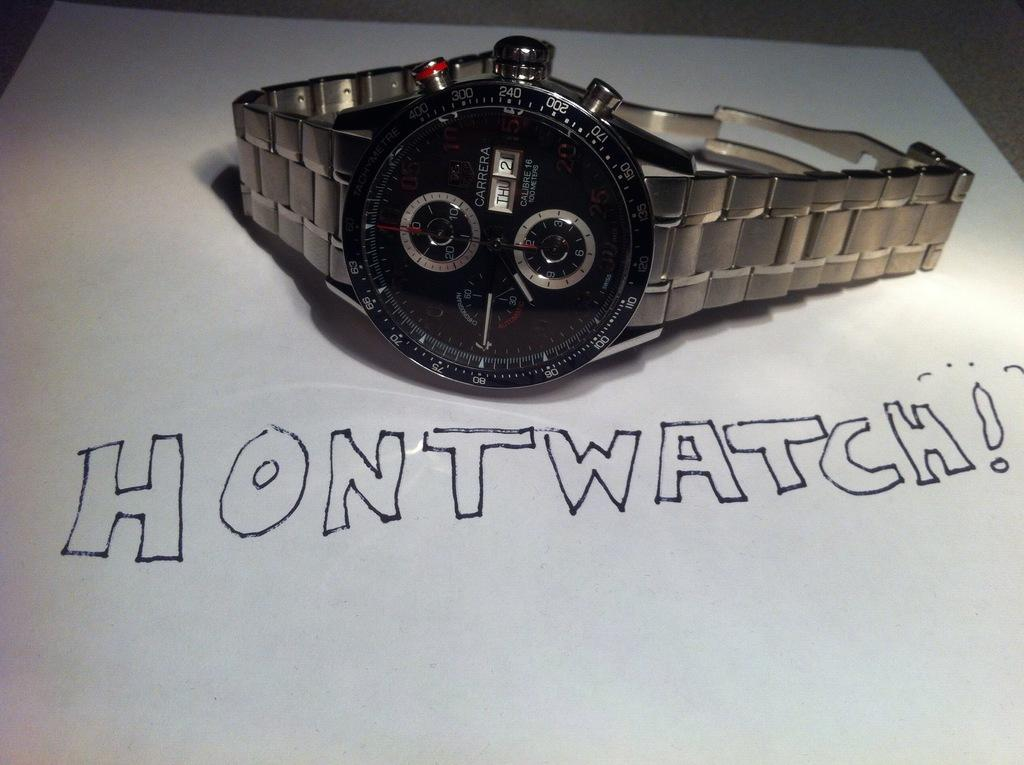<image>
Give a short and clear explanation of the subsequent image. A wristwatch sitting on top of a piece of paper that says "hontwatch!". 